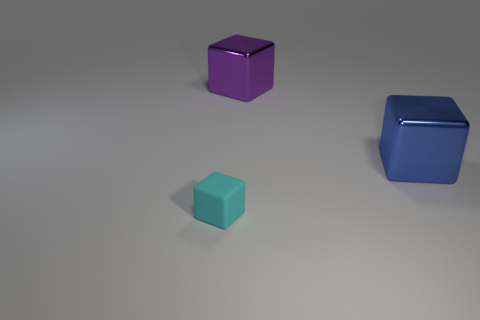What can you infer about the setting of these objects based on their shadows and reflections? The shadows are soft and somewhat elongated, indicating a light source that's not directly overhead but possibly at an angle. There are no distinct reflections on the surface beneath the objects, which could imply a non-reflective or matte surface they're resting on. What might that say about the environment in which these objects are placed? The controlled lighting and lack of reflection suggest these objects might be situated in a studio setting designed to minimize distractions and focus solely on the objects themselves. 